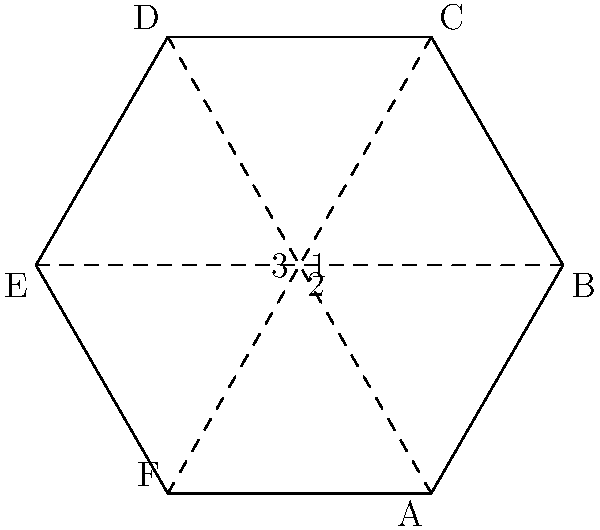A hexagonal campaign flyer is designed with three fold lines as shown. If the flyer is folded along these lines in any order, which two points will always meet regardless of the folding sequence? To solve this problem, we need to analyze the folding patterns:

1. The flyer is hexagonal, with vertices labeled A through F.
2. There are three fold lines: 1 (AD), 2 (BE), and 3 (CF).
3. We need to determine which two points will always meet, regardless of the folding order.

Let's consider the folding process:

- If we fold along line 1 (AD), point A meets point D.
- If we fold along line 2 (BE), point B meets point E.
- If we fold along line 3 (CF), point C meets point F.

Now, let's analyze the intersections of these fold lines:

- Lines 1 and 2 intersect at the center of the hexagon.
- Lines 2 and 3 intersect at the center of the hexagon.
- Lines 1 and 3 intersect at the center of the hexagon.

This means that all three fold lines pass through the center of the hexagon. 

Regardless of the folding sequence:
- Folding along any two lines will bring four points to the center.
- The final fold will bring the remaining two points to the center.

Therefore, all six points (A, B, C, D, E, and F) will meet at the center of the hexagon after all three folds are made, regardless of the order of folding.

However, the question asks for two points that will always meet. The only way to guarantee this is to choose opposite points, which are connected by a fold line. These pairs are:

- A and D (connected by fold line 1)
- B and E (connected by fold line 2)
- C and F (connected by fold line 3)

Any of these pairs will always meet, regardless of the folding sequence.
Answer: A and D 